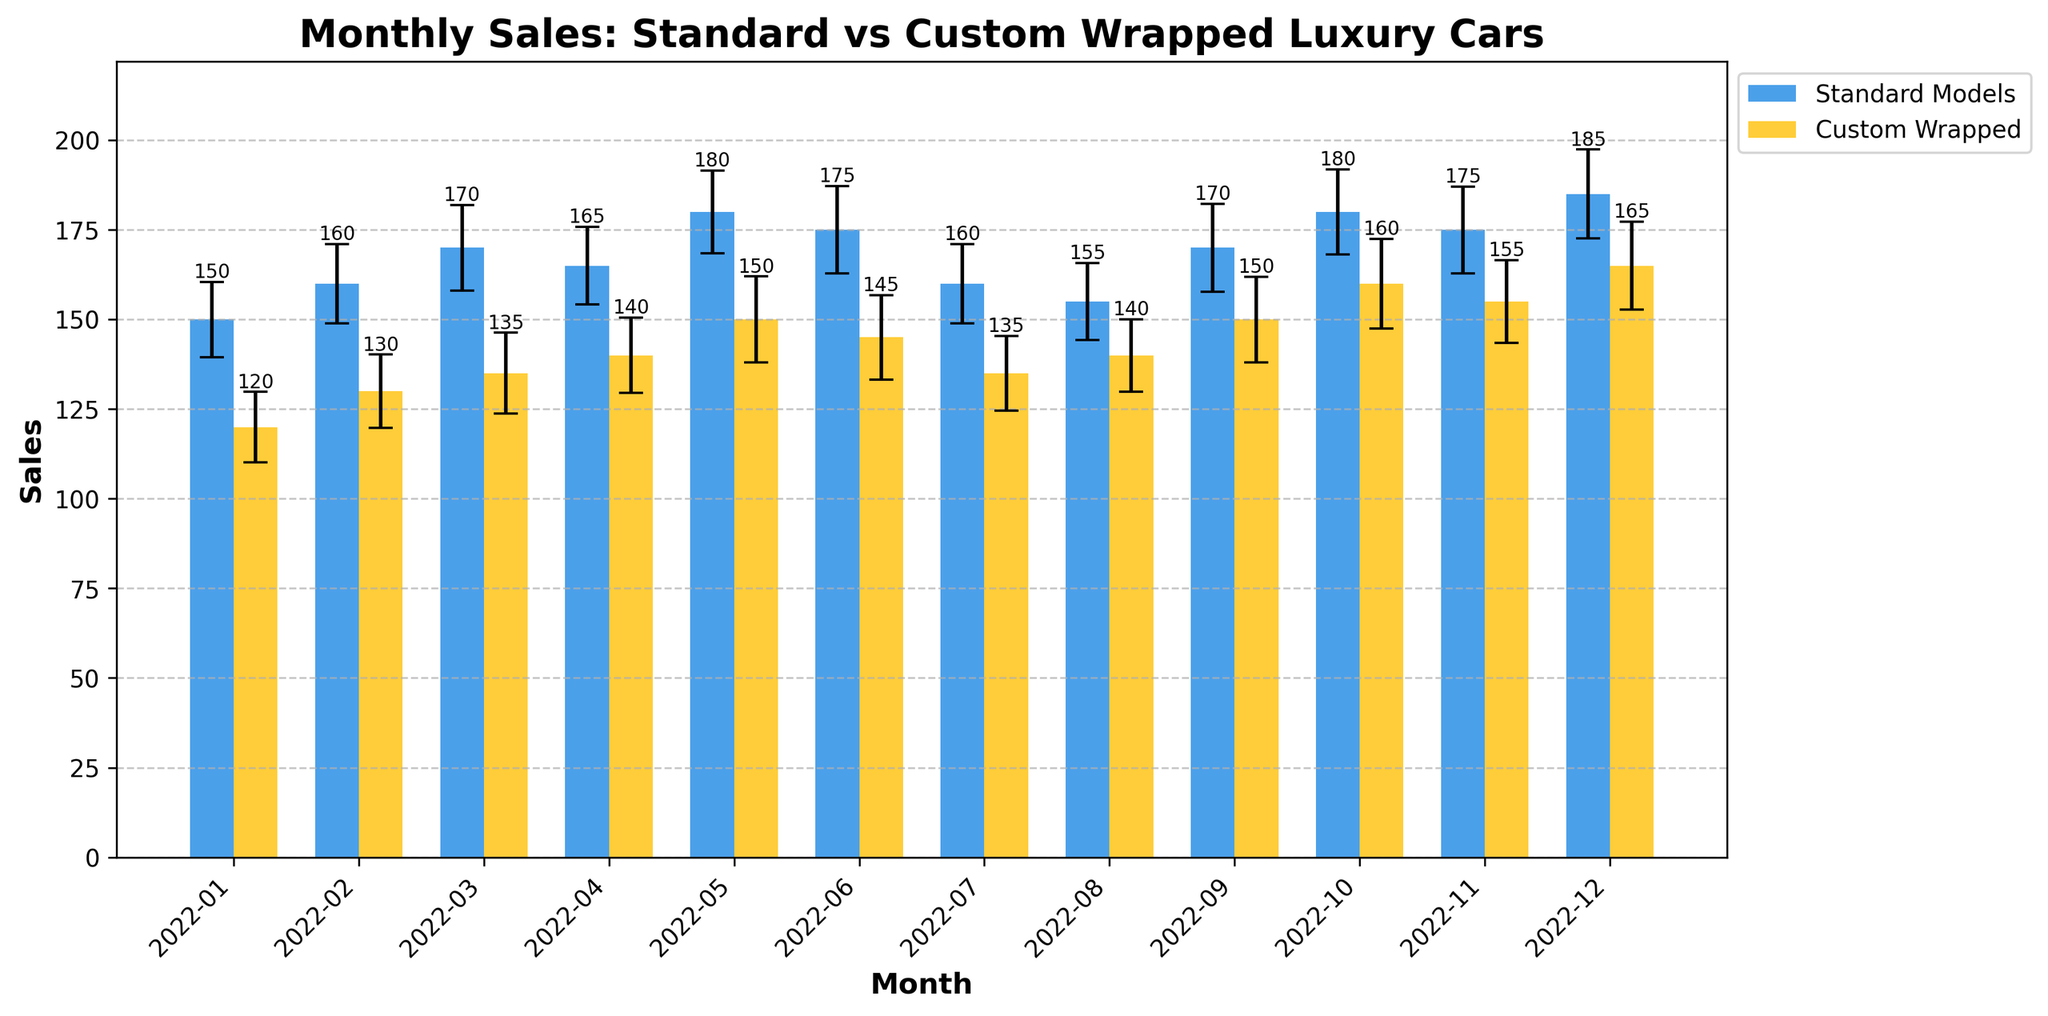What's the title of the figure? The title is displayed at the top of the plot and it reads, "Monthly Sales: Standard vs Custom Wrapped Luxury Cars".
Answer: Monthly Sales: Standard vs Custom Wrapped Luxury Cars How many months are displayed in the plot? Each bar represents sales data for one month, and there are 12 bars for each sales type indicating the total number of months represented is 12.
Answer: 12 Which month had the highest sales for standard models? By examining the height of the bars for standard model sales, the December bar is the highest.
Answer: December What was the sales difference between custom wrapped and standard models in December? The sales of standard models in December were 185 and for custom wrapped models were 165. The difference is 185 - 165.
Answer: 20 What is the average sales for custom wrapped models over the year? Sum up the custom wrapped sales for each month and divide by the number of months: (120 + 130 + 135 + 140 + 150 + 145 + 135 + 140 + 150 + 160 + 155 + 165)/12.
Answer: 144.58 Which month showed the smallest sales difference between standard and custom wrapped models? In January, the difference is calculated as 150 - 120 = 30, in February it's 160 - 130 = 30, in March it's 170 - 135 = 35, in April it's 165 - 140 = 25, and so on. The smallest difference is in April.
Answer: April Which type of model had higher error bars on average? To determine the average error of each model, sum the errors for each month and divide by 12. Compute (10.5 + 11 + 12 + 10.8 + 11.5 + 12.2 + 11 + 10.7 + 12.3 + 11.9 + 12.1 + 12.4)/12 for standard and (9.8 + 10.2 + 11.3 + 10.5 + 12 + 11.8 + 10.4 + 10.1 + 11.9 + 12.5 + 11.6 + 12.3)/12 for custom wrapped models. Standard errors are slightly higher.
Answer: Standard Models How much did standard model sales increase from January to December? The sales in January were 150 and in December were 185. The increase is calculated as 185 - 150.
Answer: 35 Did custom wrapped models ever have higher sales than standard models in any month? By examining the height of the bars for each month, the custom wrapped models had lower sales in every month compared to standard models.
Answer: No For which months did the custom-wrapped models have the smallest error bars? By observing the size of the error bars for custom wrapped models, the smallest one appears in the month of August since the error bars are visually smallest.
Answer: August 